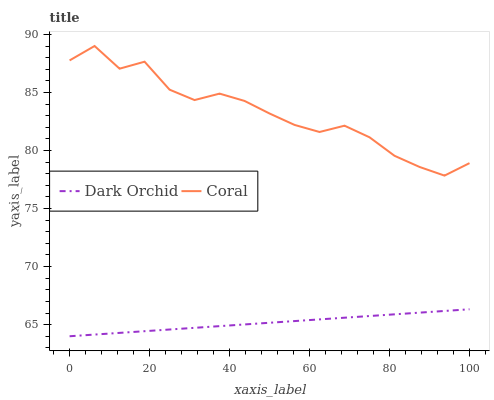Does Dark Orchid have the minimum area under the curve?
Answer yes or no. Yes. Does Coral have the maximum area under the curve?
Answer yes or no. Yes. Does Dark Orchid have the maximum area under the curve?
Answer yes or no. No. Is Dark Orchid the smoothest?
Answer yes or no. Yes. Is Coral the roughest?
Answer yes or no. Yes. Is Dark Orchid the roughest?
Answer yes or no. No. Does Dark Orchid have the highest value?
Answer yes or no. No. Is Dark Orchid less than Coral?
Answer yes or no. Yes. Is Coral greater than Dark Orchid?
Answer yes or no. Yes. Does Dark Orchid intersect Coral?
Answer yes or no. No. 